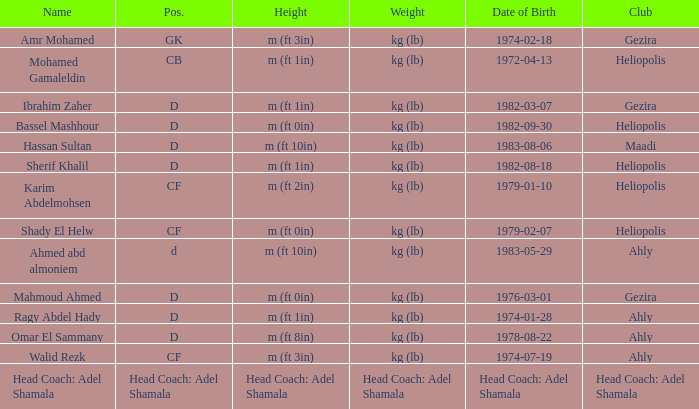What is Pos., when Height is "m (ft 10in)", and when Date of Birth is "1983-05-29"? D. 